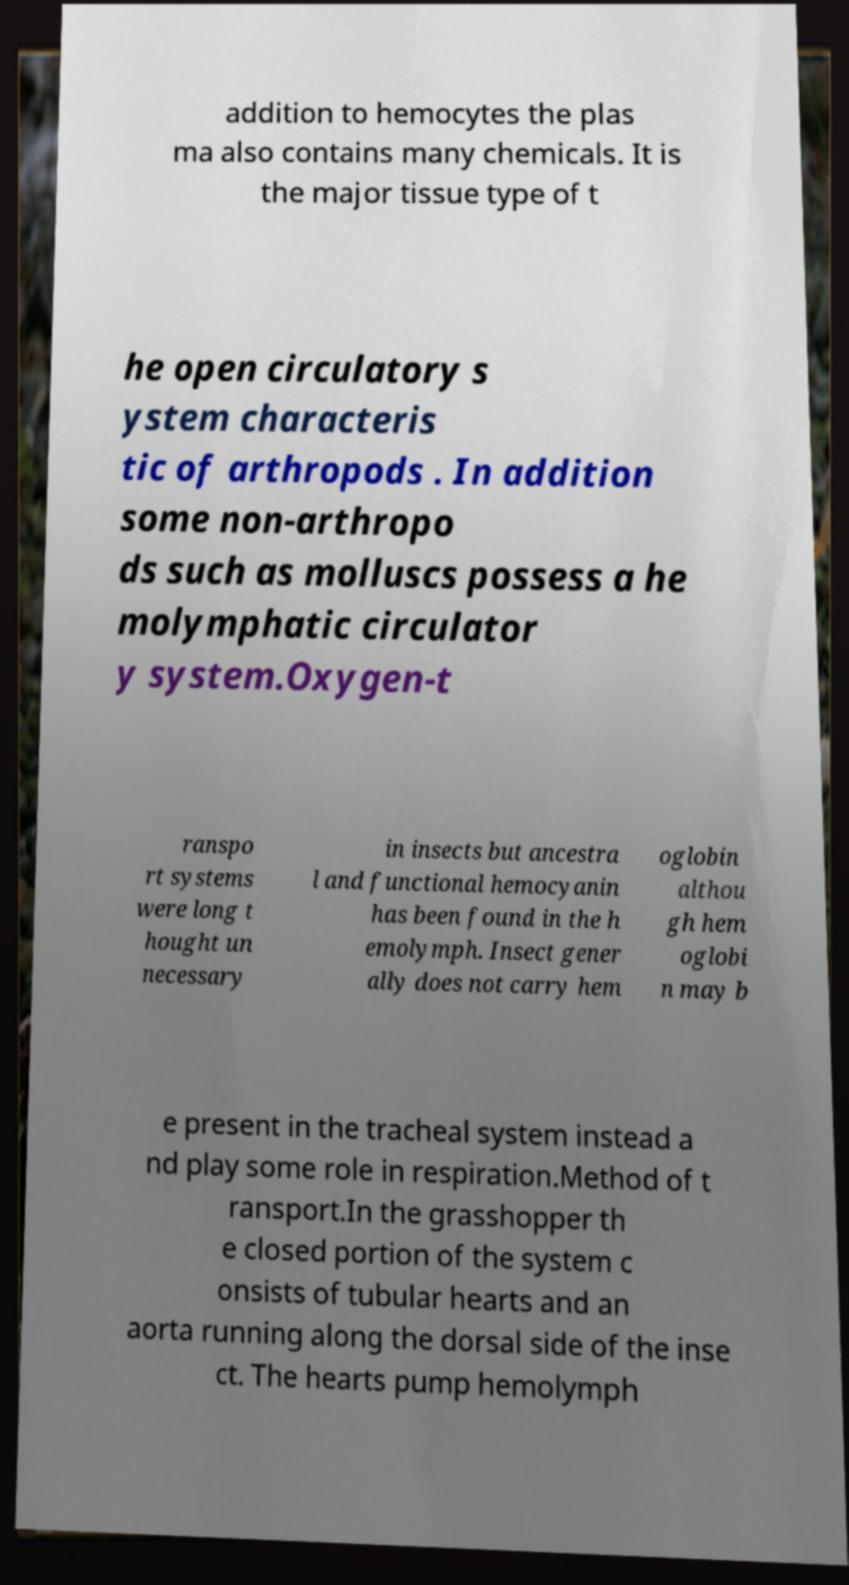Could you extract and type out the text from this image? addition to hemocytes the plas ma also contains many chemicals. It is the major tissue type of t he open circulatory s ystem characteris tic of arthropods . In addition some non-arthropo ds such as molluscs possess a he molymphatic circulator y system.Oxygen-t ranspo rt systems were long t hought un necessary in insects but ancestra l and functional hemocyanin has been found in the h emolymph. Insect gener ally does not carry hem oglobin althou gh hem oglobi n may b e present in the tracheal system instead a nd play some role in respiration.Method of t ransport.In the grasshopper th e closed portion of the system c onsists of tubular hearts and an aorta running along the dorsal side of the inse ct. The hearts pump hemolymph 